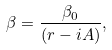Convert formula to latex. <formula><loc_0><loc_0><loc_500><loc_500>\beta = \frac { \beta _ { 0 } } { \left ( r - i A \right ) } ,</formula> 